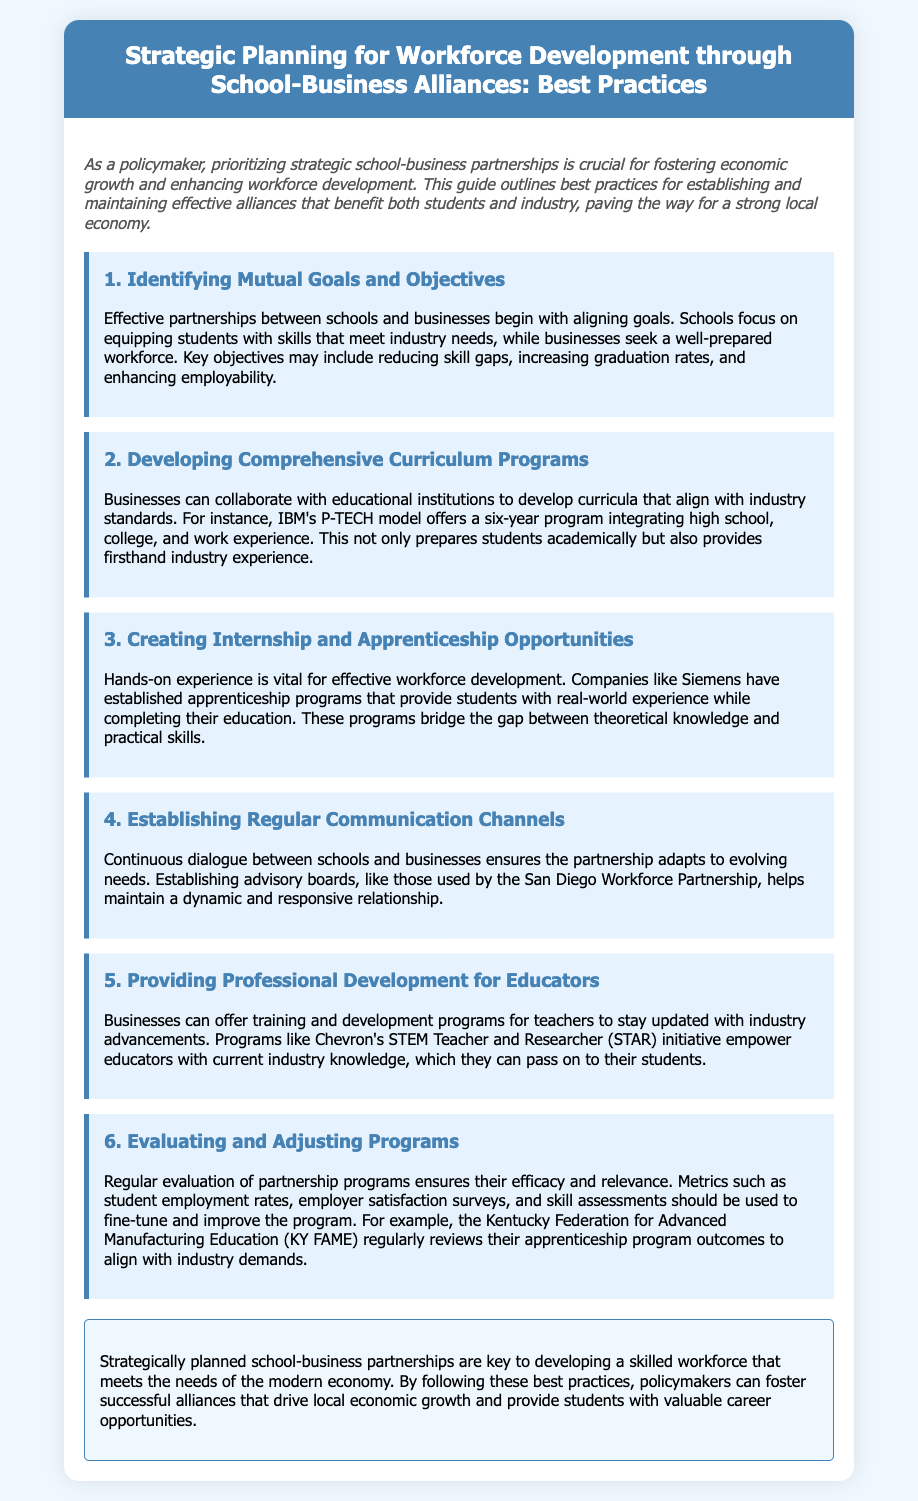What is the title of the document? The title is stated in the header of the document, clearly indicating the focus on strategic planning for workforce development.
Answer: Strategic Planning for Workforce Development through School-Business Alliances: Best Practices What is the first step in the best practices? The first step is listed as the initial entry in the recipe steps, indicating the foundational action for partnerships.
Answer: Identifying Mutual Goals and Objectives Which model is mentioned as an example in the document? The model is highlighted as a successful collaboration between businesses and educational institutions for curriculum development.
Answer: IBM's P-TECH model What initiative does Chevron offer for educators? This initiative is specifically mentioned in the document as a program to enhance teachers' skills with industry knowledge.
Answer: STEM Teacher and Researcher (STAR) How many steps are outlined in the best practices? The document lists the steps, and counting them provides the total number of outlined practices.
Answer: Six What type of experience does Siemens provide for students? The document emphasizes the hands-on experience offered through this specific type of educational program.
Answer: Apprenticeship programs What should be created to ensure ongoing communication between schools and businesses? The document specifies a structural element necessary for maintaining dialogue in partnerships.
Answer: Advisory boards What type of metrics should be used to evaluate programs? Metrics are detailed in the document for assessing the success of partnerships and ensuring relevance.
Answer: Student employment rates, employer satisfaction surveys, and skill assessments 